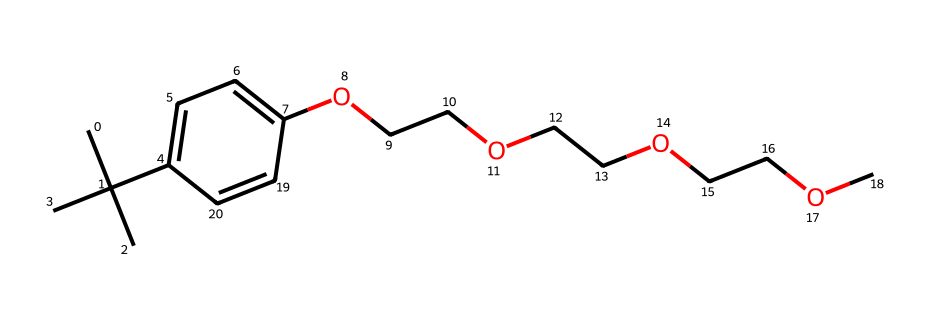What is the backbone structure of this chemical? The chemical has a long hydrocarbon tail with a phenolic group. The backbone consists of a benzene ring connected to a long ethylene glycol chain via ether linkages.
Answer: phenolic ether How many ethylene glycol units are present in this structure? By analyzing the structure, the chain features three ethylene glycol repeating units (OCC), which can be counted directly from the chain.
Answer: three What type of surfactant is represented by this compound? Nonylphenol ethoxylates are categorized as nonionic surfactants due to the absence of ionic groups in their structure, relying on hydrophilic ethylene glycol units.
Answer: nonionic What is the significance of the branched alkyl group in this detergent? The branched alkyl group contributes to the hydrophobic characteristics of the nonylphenol ethoxylate, enhancing its ability to reduce surface tension and improve cleaning efficacy.
Answer: hydrophobic characteristics Which functional group is present between the aromatic ring and the ethylene glycol units? The presence of an ether functional group (–O–) is indicated by the connection between the phenolic hydroxyl group and the ethylene glycol units in the structure.
Answer: ether 